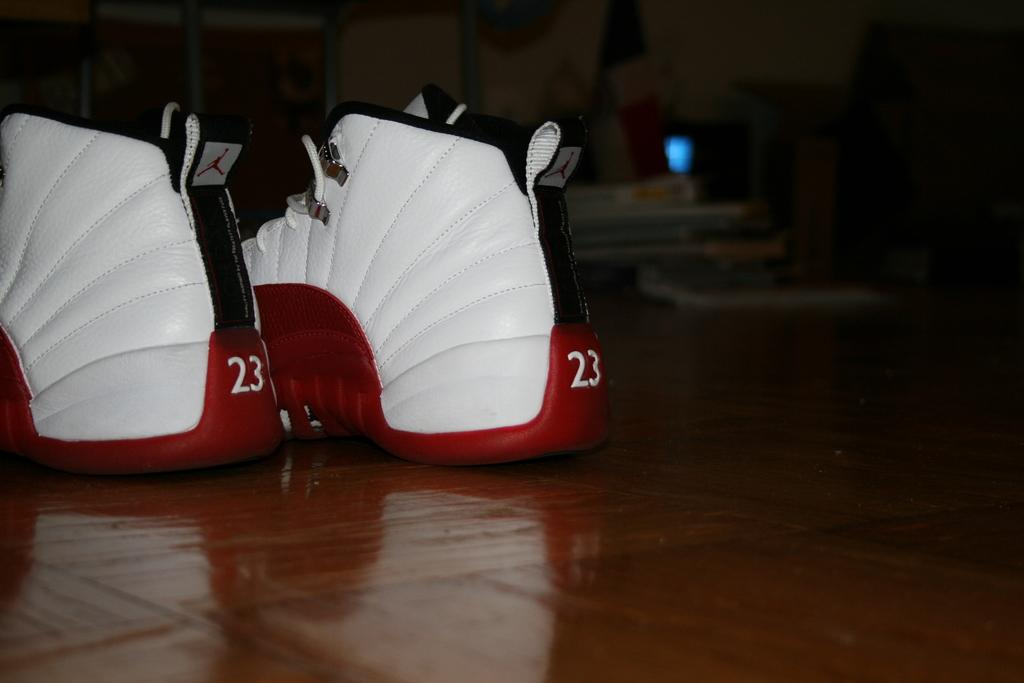What objects are present in the image? There are two shoes in the image. What can be seen in the background of the image? There are books in the background of the image. How would you describe the background of the image? The background of the image appears blurry. What type of park is visible in the background of the image? There is no park visible in the background of the image; it features books instead. 